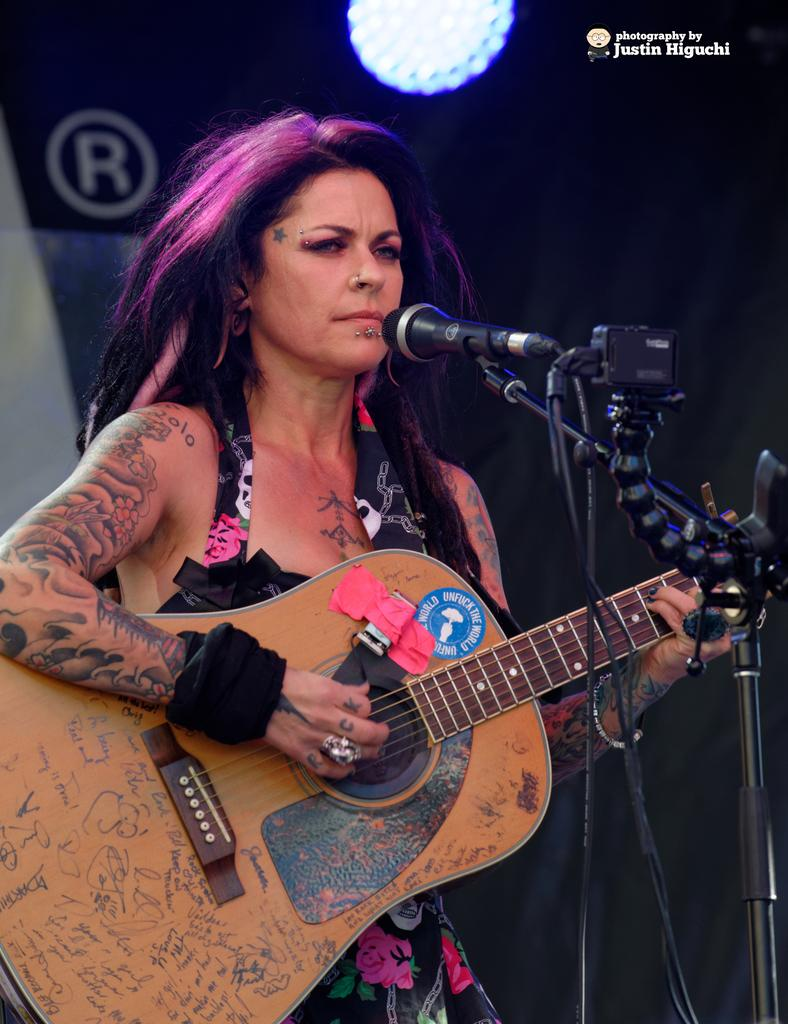Who is the main subject in the image? There is a woman in the image. What is the woman holding in the image? The woman is holding a guitar. What object is in front of the woman? There is a microphone (mic) in front of her. What type of plough is the woman using in the image? There is no plough present in the image; it features a woman holding a guitar and standing in front of a microphone. 